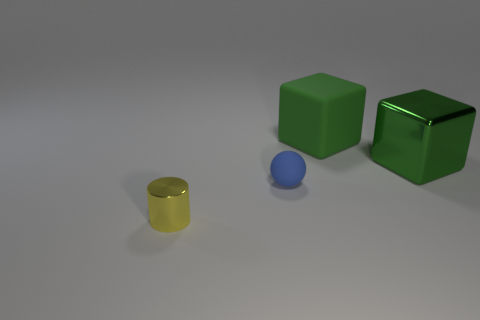The large green block that is to the right of the matte thing that is to the right of the small blue sphere is made of what material?
Offer a terse response. Metal. The big block that is right of the large green thing behind the big cube that is right of the large rubber object is what color?
Give a very brief answer. Green. Do the small rubber thing and the tiny metal cylinder have the same color?
Make the answer very short. No. How many yellow metallic cylinders have the same size as the green metal thing?
Offer a very short reply. 0. Are there more large metallic blocks right of the shiny block than matte things that are behind the blue sphere?
Keep it short and to the point. No. There is a rubber thing right of the tiny thing that is behind the tiny metallic cylinder; what color is it?
Offer a very short reply. Green. Do the sphere and the tiny cylinder have the same material?
Your answer should be very brief. No. Are there any other tiny green matte objects of the same shape as the tiny matte object?
Your answer should be compact. No. Is the color of the big block to the left of the big green shiny thing the same as the small matte object?
Provide a succinct answer. No. There is a block on the left side of the big metallic block; is its size the same as the metallic thing on the right side of the small metallic object?
Provide a succinct answer. Yes. 